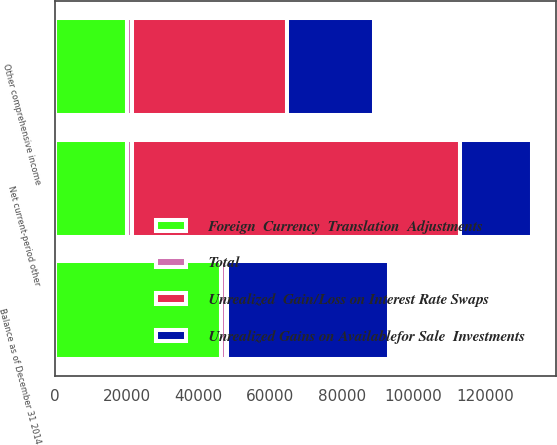<chart> <loc_0><loc_0><loc_500><loc_500><stacked_bar_chart><ecel><fcel>Other comprehensive income<fcel>Net current-period other<fcel>Balance as of December 31 2014<nl><fcel>Unrealized  Gain/Loss on Interest Rate Swaps<fcel>43045<fcel>91306<fcel>329<nl><fcel>Foreign  Currency  Translation  Adjustments<fcel>20202<fcel>20202<fcel>46197<nl><fcel>Total<fcel>1404<fcel>1404<fcel>1404<nl><fcel>Unrealized Gains on Availablefor Sale  Investments<fcel>24247<fcel>20202<fcel>45122<nl></chart> 